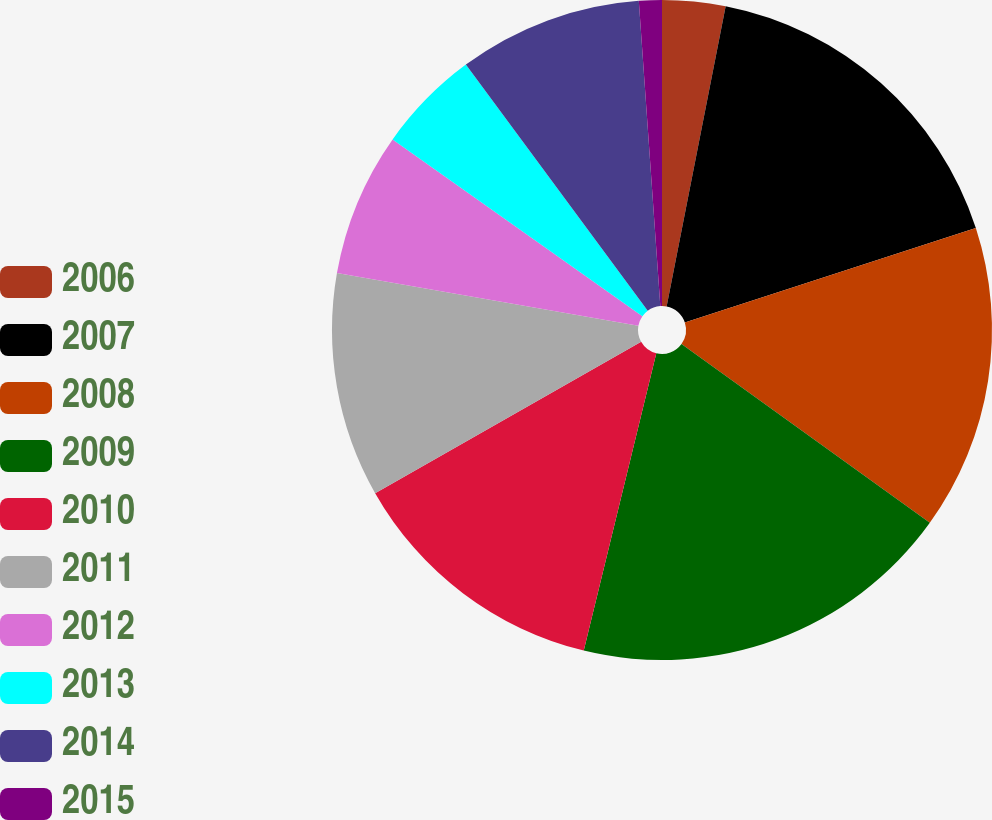Convert chart to OTSL. <chart><loc_0><loc_0><loc_500><loc_500><pie_chart><fcel>2006<fcel>2007<fcel>2008<fcel>2009<fcel>2010<fcel>2011<fcel>2012<fcel>2013<fcel>2014<fcel>2015<nl><fcel>3.09%<fcel>16.91%<fcel>14.93%<fcel>18.88%<fcel>12.96%<fcel>10.99%<fcel>7.04%<fcel>5.07%<fcel>9.01%<fcel>1.12%<nl></chart> 